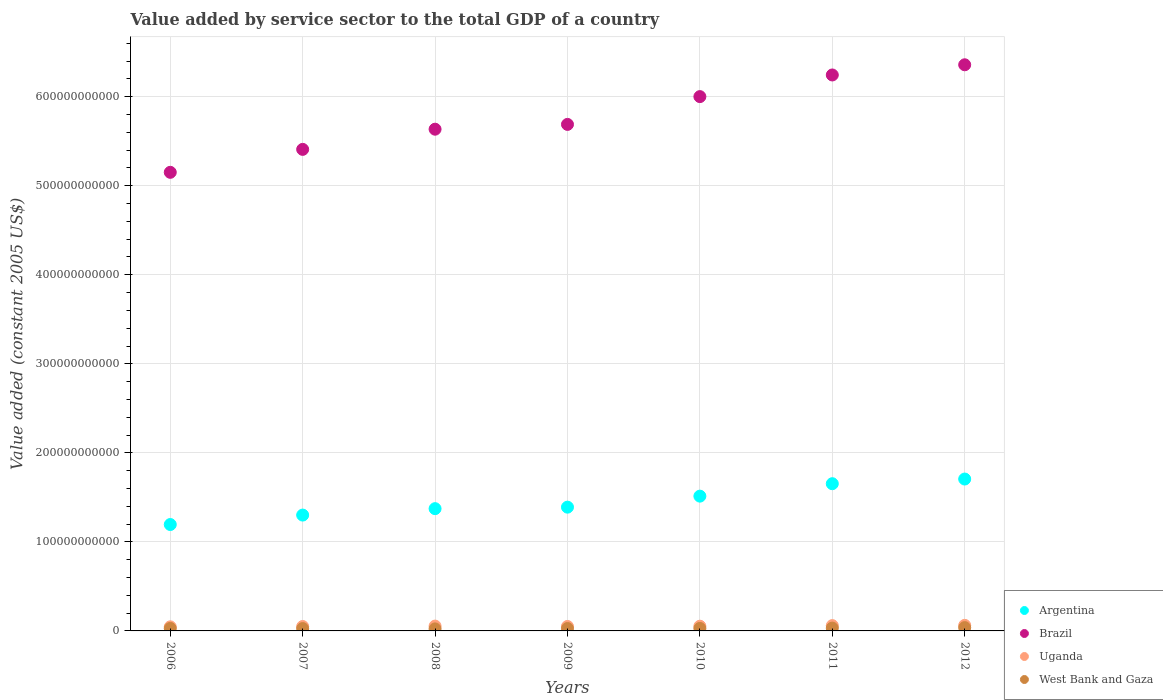What is the value added by service sector in Uganda in 2010?
Your answer should be compact. 5.30e+09. Across all years, what is the maximum value added by service sector in Uganda?
Provide a short and direct response. 6.25e+09. Across all years, what is the minimum value added by service sector in West Bank and Gaza?
Make the answer very short. 2.28e+09. In which year was the value added by service sector in Argentina minimum?
Your answer should be compact. 2006. What is the total value added by service sector in Uganda in the graph?
Keep it short and to the point. 3.75e+1. What is the difference between the value added by service sector in Brazil in 2008 and that in 2010?
Your answer should be very brief. -3.66e+1. What is the difference between the value added by service sector in Argentina in 2006 and the value added by service sector in West Bank and Gaza in 2010?
Keep it short and to the point. 1.17e+11. What is the average value added by service sector in Brazil per year?
Keep it short and to the point. 5.78e+11. In the year 2007, what is the difference between the value added by service sector in Brazil and value added by service sector in West Bank and Gaza?
Your answer should be compact. 5.38e+11. In how many years, is the value added by service sector in Argentina greater than 640000000000 US$?
Your answer should be very brief. 0. What is the ratio of the value added by service sector in Brazil in 2010 to that in 2012?
Your response must be concise. 0.94. Is the value added by service sector in West Bank and Gaza in 2008 less than that in 2012?
Ensure brevity in your answer.  Yes. Is the difference between the value added by service sector in Brazil in 2006 and 2011 greater than the difference between the value added by service sector in West Bank and Gaza in 2006 and 2011?
Ensure brevity in your answer.  No. What is the difference between the highest and the second highest value added by service sector in Argentina?
Your response must be concise. 5.24e+09. What is the difference between the highest and the lowest value added by service sector in Uganda?
Provide a short and direct response. 1.67e+09. In how many years, is the value added by service sector in Brazil greater than the average value added by service sector in Brazil taken over all years?
Your answer should be very brief. 3. Is the sum of the value added by service sector in West Bank and Gaza in 2006 and 2012 greater than the maximum value added by service sector in Uganda across all years?
Your response must be concise. Yes. Is it the case that in every year, the sum of the value added by service sector in Brazil and value added by service sector in Argentina  is greater than the value added by service sector in West Bank and Gaza?
Provide a succinct answer. Yes. Does the value added by service sector in West Bank and Gaza monotonically increase over the years?
Your answer should be compact. No. Is the value added by service sector in West Bank and Gaza strictly greater than the value added by service sector in Brazil over the years?
Offer a terse response. No. How many dotlines are there?
Provide a short and direct response. 4. How many years are there in the graph?
Keep it short and to the point. 7. What is the difference between two consecutive major ticks on the Y-axis?
Your answer should be very brief. 1.00e+11. Does the graph contain any zero values?
Your response must be concise. No. Does the graph contain grids?
Offer a very short reply. Yes. Where does the legend appear in the graph?
Offer a very short reply. Bottom right. How many legend labels are there?
Keep it short and to the point. 4. What is the title of the graph?
Provide a succinct answer. Value added by service sector to the total GDP of a country. Does "Estonia" appear as one of the legend labels in the graph?
Your answer should be very brief. No. What is the label or title of the Y-axis?
Provide a succinct answer. Value added (constant 2005 US$). What is the Value added (constant 2005 US$) in Argentina in 2006?
Offer a terse response. 1.19e+11. What is the Value added (constant 2005 US$) in Brazil in 2006?
Ensure brevity in your answer.  5.15e+11. What is the Value added (constant 2005 US$) of Uganda in 2006?
Give a very brief answer. 4.58e+09. What is the Value added (constant 2005 US$) in West Bank and Gaza in 2006?
Offer a very short reply. 2.79e+09. What is the Value added (constant 2005 US$) of Argentina in 2007?
Provide a succinct answer. 1.30e+11. What is the Value added (constant 2005 US$) of Brazil in 2007?
Ensure brevity in your answer.  5.41e+11. What is the Value added (constant 2005 US$) in Uganda in 2007?
Your answer should be very brief. 4.95e+09. What is the Value added (constant 2005 US$) of West Bank and Gaza in 2007?
Provide a succinct answer. 2.63e+09. What is the Value added (constant 2005 US$) in Argentina in 2008?
Make the answer very short. 1.37e+11. What is the Value added (constant 2005 US$) in Brazil in 2008?
Provide a succinct answer. 5.64e+11. What is the Value added (constant 2005 US$) in Uganda in 2008?
Give a very brief answer. 5.43e+09. What is the Value added (constant 2005 US$) of West Bank and Gaza in 2008?
Give a very brief answer. 2.28e+09. What is the Value added (constant 2005 US$) of Argentina in 2009?
Offer a terse response. 1.39e+11. What is the Value added (constant 2005 US$) of Brazil in 2009?
Offer a terse response. 5.69e+11. What is the Value added (constant 2005 US$) of Uganda in 2009?
Your answer should be very brief. 5.00e+09. What is the Value added (constant 2005 US$) in West Bank and Gaza in 2009?
Offer a very short reply. 2.69e+09. What is the Value added (constant 2005 US$) of Argentina in 2010?
Give a very brief answer. 1.51e+11. What is the Value added (constant 2005 US$) in Brazil in 2010?
Provide a succinct answer. 6.00e+11. What is the Value added (constant 2005 US$) in Uganda in 2010?
Give a very brief answer. 5.30e+09. What is the Value added (constant 2005 US$) in West Bank and Gaza in 2010?
Your answer should be compact. 2.80e+09. What is the Value added (constant 2005 US$) of Argentina in 2011?
Your answer should be compact. 1.65e+11. What is the Value added (constant 2005 US$) of Brazil in 2011?
Offer a very short reply. 6.24e+11. What is the Value added (constant 2005 US$) in Uganda in 2011?
Provide a succinct answer. 5.96e+09. What is the Value added (constant 2005 US$) of West Bank and Gaza in 2011?
Keep it short and to the point. 3.15e+09. What is the Value added (constant 2005 US$) in Argentina in 2012?
Your answer should be compact. 1.71e+11. What is the Value added (constant 2005 US$) in Brazil in 2012?
Offer a very short reply. 6.36e+11. What is the Value added (constant 2005 US$) in Uganda in 2012?
Provide a succinct answer. 6.25e+09. What is the Value added (constant 2005 US$) of West Bank and Gaza in 2012?
Your answer should be very brief. 3.69e+09. Across all years, what is the maximum Value added (constant 2005 US$) in Argentina?
Make the answer very short. 1.71e+11. Across all years, what is the maximum Value added (constant 2005 US$) in Brazil?
Your answer should be very brief. 6.36e+11. Across all years, what is the maximum Value added (constant 2005 US$) in Uganda?
Give a very brief answer. 6.25e+09. Across all years, what is the maximum Value added (constant 2005 US$) in West Bank and Gaza?
Provide a short and direct response. 3.69e+09. Across all years, what is the minimum Value added (constant 2005 US$) in Argentina?
Keep it short and to the point. 1.19e+11. Across all years, what is the minimum Value added (constant 2005 US$) of Brazil?
Provide a succinct answer. 5.15e+11. Across all years, what is the minimum Value added (constant 2005 US$) of Uganda?
Provide a succinct answer. 4.58e+09. Across all years, what is the minimum Value added (constant 2005 US$) of West Bank and Gaza?
Your answer should be compact. 2.28e+09. What is the total Value added (constant 2005 US$) in Argentina in the graph?
Provide a succinct answer. 1.01e+12. What is the total Value added (constant 2005 US$) of Brazil in the graph?
Offer a very short reply. 4.05e+12. What is the total Value added (constant 2005 US$) of Uganda in the graph?
Your answer should be compact. 3.75e+1. What is the total Value added (constant 2005 US$) of West Bank and Gaza in the graph?
Keep it short and to the point. 2.00e+1. What is the difference between the Value added (constant 2005 US$) of Argentina in 2006 and that in 2007?
Provide a succinct answer. -1.06e+1. What is the difference between the Value added (constant 2005 US$) in Brazil in 2006 and that in 2007?
Offer a terse response. -2.58e+1. What is the difference between the Value added (constant 2005 US$) of Uganda in 2006 and that in 2007?
Your answer should be very brief. -3.69e+08. What is the difference between the Value added (constant 2005 US$) of West Bank and Gaza in 2006 and that in 2007?
Provide a short and direct response. 1.53e+08. What is the difference between the Value added (constant 2005 US$) of Argentina in 2006 and that in 2008?
Keep it short and to the point. -1.78e+1. What is the difference between the Value added (constant 2005 US$) in Brazil in 2006 and that in 2008?
Make the answer very short. -4.84e+1. What is the difference between the Value added (constant 2005 US$) in Uganda in 2006 and that in 2008?
Make the answer very short. -8.47e+08. What is the difference between the Value added (constant 2005 US$) in West Bank and Gaza in 2006 and that in 2008?
Offer a terse response. 5.07e+08. What is the difference between the Value added (constant 2005 US$) in Argentina in 2006 and that in 2009?
Keep it short and to the point. -1.95e+1. What is the difference between the Value added (constant 2005 US$) of Brazil in 2006 and that in 2009?
Give a very brief answer. -5.38e+1. What is the difference between the Value added (constant 2005 US$) of Uganda in 2006 and that in 2009?
Make the answer very short. -4.21e+08. What is the difference between the Value added (constant 2005 US$) of West Bank and Gaza in 2006 and that in 2009?
Offer a very short reply. 9.29e+07. What is the difference between the Value added (constant 2005 US$) in Argentina in 2006 and that in 2010?
Make the answer very short. -3.19e+1. What is the difference between the Value added (constant 2005 US$) in Brazil in 2006 and that in 2010?
Your response must be concise. -8.50e+1. What is the difference between the Value added (constant 2005 US$) in Uganda in 2006 and that in 2010?
Provide a short and direct response. -7.18e+08. What is the difference between the Value added (constant 2005 US$) of West Bank and Gaza in 2006 and that in 2010?
Your answer should be compact. -1.87e+07. What is the difference between the Value added (constant 2005 US$) of Argentina in 2006 and that in 2011?
Your answer should be very brief. -4.58e+1. What is the difference between the Value added (constant 2005 US$) of Brazil in 2006 and that in 2011?
Your answer should be compact. -1.09e+11. What is the difference between the Value added (constant 2005 US$) of Uganda in 2006 and that in 2011?
Keep it short and to the point. -1.37e+09. What is the difference between the Value added (constant 2005 US$) of West Bank and Gaza in 2006 and that in 2011?
Your answer should be very brief. -3.64e+08. What is the difference between the Value added (constant 2005 US$) of Argentina in 2006 and that in 2012?
Keep it short and to the point. -5.11e+1. What is the difference between the Value added (constant 2005 US$) in Brazil in 2006 and that in 2012?
Provide a short and direct response. -1.21e+11. What is the difference between the Value added (constant 2005 US$) of Uganda in 2006 and that in 2012?
Provide a short and direct response. -1.67e+09. What is the difference between the Value added (constant 2005 US$) of West Bank and Gaza in 2006 and that in 2012?
Provide a succinct answer. -9.06e+08. What is the difference between the Value added (constant 2005 US$) in Argentina in 2007 and that in 2008?
Offer a very short reply. -7.21e+09. What is the difference between the Value added (constant 2005 US$) of Brazil in 2007 and that in 2008?
Provide a short and direct response. -2.27e+1. What is the difference between the Value added (constant 2005 US$) in Uganda in 2007 and that in 2008?
Your answer should be compact. -4.78e+08. What is the difference between the Value added (constant 2005 US$) in West Bank and Gaza in 2007 and that in 2008?
Ensure brevity in your answer.  3.54e+08. What is the difference between the Value added (constant 2005 US$) in Argentina in 2007 and that in 2009?
Your response must be concise. -8.89e+09. What is the difference between the Value added (constant 2005 US$) in Brazil in 2007 and that in 2009?
Provide a short and direct response. -2.81e+1. What is the difference between the Value added (constant 2005 US$) of Uganda in 2007 and that in 2009?
Provide a short and direct response. -5.24e+07. What is the difference between the Value added (constant 2005 US$) in West Bank and Gaza in 2007 and that in 2009?
Your answer should be compact. -5.98e+07. What is the difference between the Value added (constant 2005 US$) of Argentina in 2007 and that in 2010?
Your answer should be compact. -2.13e+1. What is the difference between the Value added (constant 2005 US$) in Brazil in 2007 and that in 2010?
Provide a short and direct response. -5.93e+1. What is the difference between the Value added (constant 2005 US$) in Uganda in 2007 and that in 2010?
Keep it short and to the point. -3.49e+08. What is the difference between the Value added (constant 2005 US$) of West Bank and Gaza in 2007 and that in 2010?
Provide a short and direct response. -1.71e+08. What is the difference between the Value added (constant 2005 US$) in Argentina in 2007 and that in 2011?
Ensure brevity in your answer.  -3.52e+1. What is the difference between the Value added (constant 2005 US$) of Brazil in 2007 and that in 2011?
Your answer should be compact. -8.36e+1. What is the difference between the Value added (constant 2005 US$) of Uganda in 2007 and that in 2011?
Offer a terse response. -1.00e+09. What is the difference between the Value added (constant 2005 US$) of West Bank and Gaza in 2007 and that in 2011?
Make the answer very short. -5.17e+08. What is the difference between the Value added (constant 2005 US$) of Argentina in 2007 and that in 2012?
Provide a succinct answer. -4.05e+1. What is the difference between the Value added (constant 2005 US$) in Brazil in 2007 and that in 2012?
Give a very brief answer. -9.50e+1. What is the difference between the Value added (constant 2005 US$) of Uganda in 2007 and that in 2012?
Provide a short and direct response. -1.30e+09. What is the difference between the Value added (constant 2005 US$) of West Bank and Gaza in 2007 and that in 2012?
Offer a terse response. -1.06e+09. What is the difference between the Value added (constant 2005 US$) in Argentina in 2008 and that in 2009?
Offer a very short reply. -1.68e+09. What is the difference between the Value added (constant 2005 US$) of Brazil in 2008 and that in 2009?
Make the answer very short. -5.39e+09. What is the difference between the Value added (constant 2005 US$) in Uganda in 2008 and that in 2009?
Offer a terse response. 4.26e+08. What is the difference between the Value added (constant 2005 US$) in West Bank and Gaza in 2008 and that in 2009?
Ensure brevity in your answer.  -4.14e+08. What is the difference between the Value added (constant 2005 US$) of Argentina in 2008 and that in 2010?
Offer a terse response. -1.41e+1. What is the difference between the Value added (constant 2005 US$) in Brazil in 2008 and that in 2010?
Keep it short and to the point. -3.66e+1. What is the difference between the Value added (constant 2005 US$) of Uganda in 2008 and that in 2010?
Offer a very short reply. 1.29e+08. What is the difference between the Value added (constant 2005 US$) in West Bank and Gaza in 2008 and that in 2010?
Give a very brief answer. -5.26e+08. What is the difference between the Value added (constant 2005 US$) in Argentina in 2008 and that in 2011?
Your answer should be compact. -2.80e+1. What is the difference between the Value added (constant 2005 US$) in Brazil in 2008 and that in 2011?
Offer a terse response. -6.09e+1. What is the difference between the Value added (constant 2005 US$) in Uganda in 2008 and that in 2011?
Your answer should be very brief. -5.27e+08. What is the difference between the Value added (constant 2005 US$) in West Bank and Gaza in 2008 and that in 2011?
Give a very brief answer. -8.71e+08. What is the difference between the Value added (constant 2005 US$) of Argentina in 2008 and that in 2012?
Make the answer very short. -3.33e+1. What is the difference between the Value added (constant 2005 US$) of Brazil in 2008 and that in 2012?
Offer a terse response. -7.24e+1. What is the difference between the Value added (constant 2005 US$) of Uganda in 2008 and that in 2012?
Your answer should be very brief. -8.21e+08. What is the difference between the Value added (constant 2005 US$) in West Bank and Gaza in 2008 and that in 2012?
Keep it short and to the point. -1.41e+09. What is the difference between the Value added (constant 2005 US$) of Argentina in 2009 and that in 2010?
Your answer should be compact. -1.24e+1. What is the difference between the Value added (constant 2005 US$) in Brazil in 2009 and that in 2010?
Offer a terse response. -3.12e+1. What is the difference between the Value added (constant 2005 US$) of Uganda in 2009 and that in 2010?
Keep it short and to the point. -2.97e+08. What is the difference between the Value added (constant 2005 US$) in West Bank and Gaza in 2009 and that in 2010?
Your answer should be compact. -1.12e+08. What is the difference between the Value added (constant 2005 US$) in Argentina in 2009 and that in 2011?
Your response must be concise. -2.63e+1. What is the difference between the Value added (constant 2005 US$) of Brazil in 2009 and that in 2011?
Offer a very short reply. -5.55e+1. What is the difference between the Value added (constant 2005 US$) of Uganda in 2009 and that in 2011?
Give a very brief answer. -9.52e+08. What is the difference between the Value added (constant 2005 US$) of West Bank and Gaza in 2009 and that in 2011?
Your answer should be very brief. -4.57e+08. What is the difference between the Value added (constant 2005 US$) of Argentina in 2009 and that in 2012?
Ensure brevity in your answer.  -3.16e+1. What is the difference between the Value added (constant 2005 US$) in Brazil in 2009 and that in 2012?
Provide a short and direct response. -6.70e+1. What is the difference between the Value added (constant 2005 US$) in Uganda in 2009 and that in 2012?
Your response must be concise. -1.25e+09. What is the difference between the Value added (constant 2005 US$) of West Bank and Gaza in 2009 and that in 2012?
Keep it short and to the point. -9.99e+08. What is the difference between the Value added (constant 2005 US$) of Argentina in 2010 and that in 2011?
Provide a short and direct response. -1.40e+1. What is the difference between the Value added (constant 2005 US$) of Brazil in 2010 and that in 2011?
Your answer should be compact. -2.43e+1. What is the difference between the Value added (constant 2005 US$) in Uganda in 2010 and that in 2011?
Offer a terse response. -6.55e+08. What is the difference between the Value added (constant 2005 US$) in West Bank and Gaza in 2010 and that in 2011?
Give a very brief answer. -3.45e+08. What is the difference between the Value added (constant 2005 US$) of Argentina in 2010 and that in 2012?
Your answer should be very brief. -1.92e+1. What is the difference between the Value added (constant 2005 US$) of Brazil in 2010 and that in 2012?
Your answer should be very brief. -3.57e+1. What is the difference between the Value added (constant 2005 US$) of Uganda in 2010 and that in 2012?
Provide a succinct answer. -9.49e+08. What is the difference between the Value added (constant 2005 US$) in West Bank and Gaza in 2010 and that in 2012?
Ensure brevity in your answer.  -8.88e+08. What is the difference between the Value added (constant 2005 US$) in Argentina in 2011 and that in 2012?
Keep it short and to the point. -5.24e+09. What is the difference between the Value added (constant 2005 US$) of Brazil in 2011 and that in 2012?
Your answer should be very brief. -1.14e+1. What is the difference between the Value added (constant 2005 US$) in Uganda in 2011 and that in 2012?
Make the answer very short. -2.94e+08. What is the difference between the Value added (constant 2005 US$) in West Bank and Gaza in 2011 and that in 2012?
Offer a very short reply. -5.42e+08. What is the difference between the Value added (constant 2005 US$) in Argentina in 2006 and the Value added (constant 2005 US$) in Brazil in 2007?
Your response must be concise. -4.21e+11. What is the difference between the Value added (constant 2005 US$) of Argentina in 2006 and the Value added (constant 2005 US$) of Uganda in 2007?
Your answer should be compact. 1.15e+11. What is the difference between the Value added (constant 2005 US$) in Argentina in 2006 and the Value added (constant 2005 US$) in West Bank and Gaza in 2007?
Your answer should be very brief. 1.17e+11. What is the difference between the Value added (constant 2005 US$) of Brazil in 2006 and the Value added (constant 2005 US$) of Uganda in 2007?
Your answer should be compact. 5.10e+11. What is the difference between the Value added (constant 2005 US$) of Brazil in 2006 and the Value added (constant 2005 US$) of West Bank and Gaza in 2007?
Offer a terse response. 5.12e+11. What is the difference between the Value added (constant 2005 US$) of Uganda in 2006 and the Value added (constant 2005 US$) of West Bank and Gaza in 2007?
Make the answer very short. 1.95e+09. What is the difference between the Value added (constant 2005 US$) in Argentina in 2006 and the Value added (constant 2005 US$) in Brazil in 2008?
Give a very brief answer. -4.44e+11. What is the difference between the Value added (constant 2005 US$) of Argentina in 2006 and the Value added (constant 2005 US$) of Uganda in 2008?
Your response must be concise. 1.14e+11. What is the difference between the Value added (constant 2005 US$) in Argentina in 2006 and the Value added (constant 2005 US$) in West Bank and Gaza in 2008?
Your answer should be compact. 1.17e+11. What is the difference between the Value added (constant 2005 US$) in Brazil in 2006 and the Value added (constant 2005 US$) in Uganda in 2008?
Your answer should be compact. 5.10e+11. What is the difference between the Value added (constant 2005 US$) of Brazil in 2006 and the Value added (constant 2005 US$) of West Bank and Gaza in 2008?
Offer a very short reply. 5.13e+11. What is the difference between the Value added (constant 2005 US$) in Uganda in 2006 and the Value added (constant 2005 US$) in West Bank and Gaza in 2008?
Offer a very short reply. 2.30e+09. What is the difference between the Value added (constant 2005 US$) of Argentina in 2006 and the Value added (constant 2005 US$) of Brazil in 2009?
Provide a succinct answer. -4.49e+11. What is the difference between the Value added (constant 2005 US$) of Argentina in 2006 and the Value added (constant 2005 US$) of Uganda in 2009?
Ensure brevity in your answer.  1.14e+11. What is the difference between the Value added (constant 2005 US$) of Argentina in 2006 and the Value added (constant 2005 US$) of West Bank and Gaza in 2009?
Ensure brevity in your answer.  1.17e+11. What is the difference between the Value added (constant 2005 US$) of Brazil in 2006 and the Value added (constant 2005 US$) of Uganda in 2009?
Provide a short and direct response. 5.10e+11. What is the difference between the Value added (constant 2005 US$) of Brazil in 2006 and the Value added (constant 2005 US$) of West Bank and Gaza in 2009?
Offer a very short reply. 5.12e+11. What is the difference between the Value added (constant 2005 US$) of Uganda in 2006 and the Value added (constant 2005 US$) of West Bank and Gaza in 2009?
Your answer should be very brief. 1.89e+09. What is the difference between the Value added (constant 2005 US$) of Argentina in 2006 and the Value added (constant 2005 US$) of Brazil in 2010?
Your response must be concise. -4.81e+11. What is the difference between the Value added (constant 2005 US$) of Argentina in 2006 and the Value added (constant 2005 US$) of Uganda in 2010?
Your answer should be very brief. 1.14e+11. What is the difference between the Value added (constant 2005 US$) of Argentina in 2006 and the Value added (constant 2005 US$) of West Bank and Gaza in 2010?
Give a very brief answer. 1.17e+11. What is the difference between the Value added (constant 2005 US$) in Brazil in 2006 and the Value added (constant 2005 US$) in Uganda in 2010?
Give a very brief answer. 5.10e+11. What is the difference between the Value added (constant 2005 US$) of Brazil in 2006 and the Value added (constant 2005 US$) of West Bank and Gaza in 2010?
Your response must be concise. 5.12e+11. What is the difference between the Value added (constant 2005 US$) in Uganda in 2006 and the Value added (constant 2005 US$) in West Bank and Gaza in 2010?
Provide a short and direct response. 1.78e+09. What is the difference between the Value added (constant 2005 US$) in Argentina in 2006 and the Value added (constant 2005 US$) in Brazil in 2011?
Your answer should be compact. -5.05e+11. What is the difference between the Value added (constant 2005 US$) in Argentina in 2006 and the Value added (constant 2005 US$) in Uganda in 2011?
Your answer should be compact. 1.14e+11. What is the difference between the Value added (constant 2005 US$) of Argentina in 2006 and the Value added (constant 2005 US$) of West Bank and Gaza in 2011?
Keep it short and to the point. 1.16e+11. What is the difference between the Value added (constant 2005 US$) in Brazil in 2006 and the Value added (constant 2005 US$) in Uganda in 2011?
Offer a very short reply. 5.09e+11. What is the difference between the Value added (constant 2005 US$) in Brazil in 2006 and the Value added (constant 2005 US$) in West Bank and Gaza in 2011?
Make the answer very short. 5.12e+11. What is the difference between the Value added (constant 2005 US$) in Uganda in 2006 and the Value added (constant 2005 US$) in West Bank and Gaza in 2011?
Your answer should be very brief. 1.43e+09. What is the difference between the Value added (constant 2005 US$) in Argentina in 2006 and the Value added (constant 2005 US$) in Brazil in 2012?
Provide a short and direct response. -5.16e+11. What is the difference between the Value added (constant 2005 US$) of Argentina in 2006 and the Value added (constant 2005 US$) of Uganda in 2012?
Ensure brevity in your answer.  1.13e+11. What is the difference between the Value added (constant 2005 US$) in Argentina in 2006 and the Value added (constant 2005 US$) in West Bank and Gaza in 2012?
Provide a short and direct response. 1.16e+11. What is the difference between the Value added (constant 2005 US$) in Brazil in 2006 and the Value added (constant 2005 US$) in Uganda in 2012?
Offer a very short reply. 5.09e+11. What is the difference between the Value added (constant 2005 US$) of Brazil in 2006 and the Value added (constant 2005 US$) of West Bank and Gaza in 2012?
Make the answer very short. 5.11e+11. What is the difference between the Value added (constant 2005 US$) in Uganda in 2006 and the Value added (constant 2005 US$) in West Bank and Gaza in 2012?
Offer a very short reply. 8.89e+08. What is the difference between the Value added (constant 2005 US$) of Argentina in 2007 and the Value added (constant 2005 US$) of Brazil in 2008?
Provide a short and direct response. -4.33e+11. What is the difference between the Value added (constant 2005 US$) of Argentina in 2007 and the Value added (constant 2005 US$) of Uganda in 2008?
Your answer should be compact. 1.25e+11. What is the difference between the Value added (constant 2005 US$) of Argentina in 2007 and the Value added (constant 2005 US$) of West Bank and Gaza in 2008?
Ensure brevity in your answer.  1.28e+11. What is the difference between the Value added (constant 2005 US$) of Brazil in 2007 and the Value added (constant 2005 US$) of Uganda in 2008?
Provide a succinct answer. 5.35e+11. What is the difference between the Value added (constant 2005 US$) in Brazil in 2007 and the Value added (constant 2005 US$) in West Bank and Gaza in 2008?
Provide a short and direct response. 5.39e+11. What is the difference between the Value added (constant 2005 US$) of Uganda in 2007 and the Value added (constant 2005 US$) of West Bank and Gaza in 2008?
Your answer should be compact. 2.67e+09. What is the difference between the Value added (constant 2005 US$) of Argentina in 2007 and the Value added (constant 2005 US$) of Brazil in 2009?
Give a very brief answer. -4.39e+11. What is the difference between the Value added (constant 2005 US$) in Argentina in 2007 and the Value added (constant 2005 US$) in Uganda in 2009?
Your answer should be very brief. 1.25e+11. What is the difference between the Value added (constant 2005 US$) in Argentina in 2007 and the Value added (constant 2005 US$) in West Bank and Gaza in 2009?
Your answer should be very brief. 1.27e+11. What is the difference between the Value added (constant 2005 US$) in Brazil in 2007 and the Value added (constant 2005 US$) in Uganda in 2009?
Make the answer very short. 5.36e+11. What is the difference between the Value added (constant 2005 US$) of Brazil in 2007 and the Value added (constant 2005 US$) of West Bank and Gaza in 2009?
Make the answer very short. 5.38e+11. What is the difference between the Value added (constant 2005 US$) of Uganda in 2007 and the Value added (constant 2005 US$) of West Bank and Gaza in 2009?
Ensure brevity in your answer.  2.26e+09. What is the difference between the Value added (constant 2005 US$) in Argentina in 2007 and the Value added (constant 2005 US$) in Brazil in 2010?
Give a very brief answer. -4.70e+11. What is the difference between the Value added (constant 2005 US$) of Argentina in 2007 and the Value added (constant 2005 US$) of Uganda in 2010?
Offer a terse response. 1.25e+11. What is the difference between the Value added (constant 2005 US$) of Argentina in 2007 and the Value added (constant 2005 US$) of West Bank and Gaza in 2010?
Keep it short and to the point. 1.27e+11. What is the difference between the Value added (constant 2005 US$) of Brazil in 2007 and the Value added (constant 2005 US$) of Uganda in 2010?
Your answer should be very brief. 5.36e+11. What is the difference between the Value added (constant 2005 US$) of Brazil in 2007 and the Value added (constant 2005 US$) of West Bank and Gaza in 2010?
Offer a very short reply. 5.38e+11. What is the difference between the Value added (constant 2005 US$) of Uganda in 2007 and the Value added (constant 2005 US$) of West Bank and Gaza in 2010?
Your answer should be very brief. 2.15e+09. What is the difference between the Value added (constant 2005 US$) in Argentina in 2007 and the Value added (constant 2005 US$) in Brazil in 2011?
Give a very brief answer. -4.94e+11. What is the difference between the Value added (constant 2005 US$) in Argentina in 2007 and the Value added (constant 2005 US$) in Uganda in 2011?
Make the answer very short. 1.24e+11. What is the difference between the Value added (constant 2005 US$) of Argentina in 2007 and the Value added (constant 2005 US$) of West Bank and Gaza in 2011?
Offer a terse response. 1.27e+11. What is the difference between the Value added (constant 2005 US$) in Brazil in 2007 and the Value added (constant 2005 US$) in Uganda in 2011?
Give a very brief answer. 5.35e+11. What is the difference between the Value added (constant 2005 US$) in Brazil in 2007 and the Value added (constant 2005 US$) in West Bank and Gaza in 2011?
Provide a short and direct response. 5.38e+11. What is the difference between the Value added (constant 2005 US$) in Uganda in 2007 and the Value added (constant 2005 US$) in West Bank and Gaza in 2011?
Provide a succinct answer. 1.80e+09. What is the difference between the Value added (constant 2005 US$) of Argentina in 2007 and the Value added (constant 2005 US$) of Brazil in 2012?
Make the answer very short. -5.06e+11. What is the difference between the Value added (constant 2005 US$) in Argentina in 2007 and the Value added (constant 2005 US$) in Uganda in 2012?
Offer a terse response. 1.24e+11. What is the difference between the Value added (constant 2005 US$) in Argentina in 2007 and the Value added (constant 2005 US$) in West Bank and Gaza in 2012?
Ensure brevity in your answer.  1.26e+11. What is the difference between the Value added (constant 2005 US$) of Brazil in 2007 and the Value added (constant 2005 US$) of Uganda in 2012?
Offer a terse response. 5.35e+11. What is the difference between the Value added (constant 2005 US$) of Brazil in 2007 and the Value added (constant 2005 US$) of West Bank and Gaza in 2012?
Your answer should be compact. 5.37e+11. What is the difference between the Value added (constant 2005 US$) in Uganda in 2007 and the Value added (constant 2005 US$) in West Bank and Gaza in 2012?
Your answer should be very brief. 1.26e+09. What is the difference between the Value added (constant 2005 US$) in Argentina in 2008 and the Value added (constant 2005 US$) in Brazil in 2009?
Give a very brief answer. -4.32e+11. What is the difference between the Value added (constant 2005 US$) of Argentina in 2008 and the Value added (constant 2005 US$) of Uganda in 2009?
Ensure brevity in your answer.  1.32e+11. What is the difference between the Value added (constant 2005 US$) in Argentina in 2008 and the Value added (constant 2005 US$) in West Bank and Gaza in 2009?
Your response must be concise. 1.35e+11. What is the difference between the Value added (constant 2005 US$) of Brazil in 2008 and the Value added (constant 2005 US$) of Uganda in 2009?
Provide a succinct answer. 5.59e+11. What is the difference between the Value added (constant 2005 US$) of Brazil in 2008 and the Value added (constant 2005 US$) of West Bank and Gaza in 2009?
Provide a succinct answer. 5.61e+11. What is the difference between the Value added (constant 2005 US$) of Uganda in 2008 and the Value added (constant 2005 US$) of West Bank and Gaza in 2009?
Give a very brief answer. 2.74e+09. What is the difference between the Value added (constant 2005 US$) of Argentina in 2008 and the Value added (constant 2005 US$) of Brazil in 2010?
Provide a succinct answer. -4.63e+11. What is the difference between the Value added (constant 2005 US$) of Argentina in 2008 and the Value added (constant 2005 US$) of Uganda in 2010?
Make the answer very short. 1.32e+11. What is the difference between the Value added (constant 2005 US$) in Argentina in 2008 and the Value added (constant 2005 US$) in West Bank and Gaza in 2010?
Ensure brevity in your answer.  1.35e+11. What is the difference between the Value added (constant 2005 US$) in Brazil in 2008 and the Value added (constant 2005 US$) in Uganda in 2010?
Make the answer very short. 5.58e+11. What is the difference between the Value added (constant 2005 US$) of Brazil in 2008 and the Value added (constant 2005 US$) of West Bank and Gaza in 2010?
Keep it short and to the point. 5.61e+11. What is the difference between the Value added (constant 2005 US$) in Uganda in 2008 and the Value added (constant 2005 US$) in West Bank and Gaza in 2010?
Offer a very short reply. 2.62e+09. What is the difference between the Value added (constant 2005 US$) in Argentina in 2008 and the Value added (constant 2005 US$) in Brazil in 2011?
Ensure brevity in your answer.  -4.87e+11. What is the difference between the Value added (constant 2005 US$) in Argentina in 2008 and the Value added (constant 2005 US$) in Uganda in 2011?
Offer a terse response. 1.31e+11. What is the difference between the Value added (constant 2005 US$) in Argentina in 2008 and the Value added (constant 2005 US$) in West Bank and Gaza in 2011?
Your answer should be compact. 1.34e+11. What is the difference between the Value added (constant 2005 US$) of Brazil in 2008 and the Value added (constant 2005 US$) of Uganda in 2011?
Give a very brief answer. 5.58e+11. What is the difference between the Value added (constant 2005 US$) of Brazil in 2008 and the Value added (constant 2005 US$) of West Bank and Gaza in 2011?
Keep it short and to the point. 5.60e+11. What is the difference between the Value added (constant 2005 US$) of Uganda in 2008 and the Value added (constant 2005 US$) of West Bank and Gaza in 2011?
Keep it short and to the point. 2.28e+09. What is the difference between the Value added (constant 2005 US$) in Argentina in 2008 and the Value added (constant 2005 US$) in Brazil in 2012?
Offer a terse response. -4.99e+11. What is the difference between the Value added (constant 2005 US$) in Argentina in 2008 and the Value added (constant 2005 US$) in Uganda in 2012?
Give a very brief answer. 1.31e+11. What is the difference between the Value added (constant 2005 US$) in Argentina in 2008 and the Value added (constant 2005 US$) in West Bank and Gaza in 2012?
Your answer should be very brief. 1.34e+11. What is the difference between the Value added (constant 2005 US$) in Brazil in 2008 and the Value added (constant 2005 US$) in Uganda in 2012?
Your response must be concise. 5.57e+11. What is the difference between the Value added (constant 2005 US$) in Brazil in 2008 and the Value added (constant 2005 US$) in West Bank and Gaza in 2012?
Offer a terse response. 5.60e+11. What is the difference between the Value added (constant 2005 US$) of Uganda in 2008 and the Value added (constant 2005 US$) of West Bank and Gaza in 2012?
Keep it short and to the point. 1.74e+09. What is the difference between the Value added (constant 2005 US$) in Argentina in 2009 and the Value added (constant 2005 US$) in Brazil in 2010?
Your response must be concise. -4.61e+11. What is the difference between the Value added (constant 2005 US$) of Argentina in 2009 and the Value added (constant 2005 US$) of Uganda in 2010?
Your answer should be very brief. 1.34e+11. What is the difference between the Value added (constant 2005 US$) in Argentina in 2009 and the Value added (constant 2005 US$) in West Bank and Gaza in 2010?
Provide a short and direct response. 1.36e+11. What is the difference between the Value added (constant 2005 US$) of Brazil in 2009 and the Value added (constant 2005 US$) of Uganda in 2010?
Offer a very short reply. 5.64e+11. What is the difference between the Value added (constant 2005 US$) in Brazil in 2009 and the Value added (constant 2005 US$) in West Bank and Gaza in 2010?
Offer a very short reply. 5.66e+11. What is the difference between the Value added (constant 2005 US$) in Uganda in 2009 and the Value added (constant 2005 US$) in West Bank and Gaza in 2010?
Your answer should be compact. 2.20e+09. What is the difference between the Value added (constant 2005 US$) in Argentina in 2009 and the Value added (constant 2005 US$) in Brazil in 2011?
Offer a terse response. -4.85e+11. What is the difference between the Value added (constant 2005 US$) in Argentina in 2009 and the Value added (constant 2005 US$) in Uganda in 2011?
Ensure brevity in your answer.  1.33e+11. What is the difference between the Value added (constant 2005 US$) in Argentina in 2009 and the Value added (constant 2005 US$) in West Bank and Gaza in 2011?
Provide a short and direct response. 1.36e+11. What is the difference between the Value added (constant 2005 US$) of Brazil in 2009 and the Value added (constant 2005 US$) of Uganda in 2011?
Keep it short and to the point. 5.63e+11. What is the difference between the Value added (constant 2005 US$) of Brazil in 2009 and the Value added (constant 2005 US$) of West Bank and Gaza in 2011?
Offer a very short reply. 5.66e+11. What is the difference between the Value added (constant 2005 US$) in Uganda in 2009 and the Value added (constant 2005 US$) in West Bank and Gaza in 2011?
Your answer should be very brief. 1.85e+09. What is the difference between the Value added (constant 2005 US$) of Argentina in 2009 and the Value added (constant 2005 US$) of Brazil in 2012?
Give a very brief answer. -4.97e+11. What is the difference between the Value added (constant 2005 US$) in Argentina in 2009 and the Value added (constant 2005 US$) in Uganda in 2012?
Your answer should be very brief. 1.33e+11. What is the difference between the Value added (constant 2005 US$) of Argentina in 2009 and the Value added (constant 2005 US$) of West Bank and Gaza in 2012?
Offer a terse response. 1.35e+11. What is the difference between the Value added (constant 2005 US$) of Brazil in 2009 and the Value added (constant 2005 US$) of Uganda in 2012?
Make the answer very short. 5.63e+11. What is the difference between the Value added (constant 2005 US$) of Brazil in 2009 and the Value added (constant 2005 US$) of West Bank and Gaza in 2012?
Keep it short and to the point. 5.65e+11. What is the difference between the Value added (constant 2005 US$) of Uganda in 2009 and the Value added (constant 2005 US$) of West Bank and Gaza in 2012?
Ensure brevity in your answer.  1.31e+09. What is the difference between the Value added (constant 2005 US$) of Argentina in 2010 and the Value added (constant 2005 US$) of Brazil in 2011?
Your response must be concise. -4.73e+11. What is the difference between the Value added (constant 2005 US$) of Argentina in 2010 and the Value added (constant 2005 US$) of Uganda in 2011?
Your answer should be very brief. 1.45e+11. What is the difference between the Value added (constant 2005 US$) of Argentina in 2010 and the Value added (constant 2005 US$) of West Bank and Gaza in 2011?
Your answer should be very brief. 1.48e+11. What is the difference between the Value added (constant 2005 US$) in Brazil in 2010 and the Value added (constant 2005 US$) in Uganda in 2011?
Give a very brief answer. 5.94e+11. What is the difference between the Value added (constant 2005 US$) of Brazil in 2010 and the Value added (constant 2005 US$) of West Bank and Gaza in 2011?
Ensure brevity in your answer.  5.97e+11. What is the difference between the Value added (constant 2005 US$) of Uganda in 2010 and the Value added (constant 2005 US$) of West Bank and Gaza in 2011?
Keep it short and to the point. 2.15e+09. What is the difference between the Value added (constant 2005 US$) in Argentina in 2010 and the Value added (constant 2005 US$) in Brazil in 2012?
Offer a terse response. -4.84e+11. What is the difference between the Value added (constant 2005 US$) in Argentina in 2010 and the Value added (constant 2005 US$) in Uganda in 2012?
Your response must be concise. 1.45e+11. What is the difference between the Value added (constant 2005 US$) of Argentina in 2010 and the Value added (constant 2005 US$) of West Bank and Gaza in 2012?
Provide a short and direct response. 1.48e+11. What is the difference between the Value added (constant 2005 US$) in Brazil in 2010 and the Value added (constant 2005 US$) in Uganda in 2012?
Give a very brief answer. 5.94e+11. What is the difference between the Value added (constant 2005 US$) in Brazil in 2010 and the Value added (constant 2005 US$) in West Bank and Gaza in 2012?
Your answer should be very brief. 5.96e+11. What is the difference between the Value added (constant 2005 US$) in Uganda in 2010 and the Value added (constant 2005 US$) in West Bank and Gaza in 2012?
Offer a terse response. 1.61e+09. What is the difference between the Value added (constant 2005 US$) in Argentina in 2011 and the Value added (constant 2005 US$) in Brazil in 2012?
Offer a terse response. -4.71e+11. What is the difference between the Value added (constant 2005 US$) of Argentina in 2011 and the Value added (constant 2005 US$) of Uganda in 2012?
Make the answer very short. 1.59e+11. What is the difference between the Value added (constant 2005 US$) of Argentina in 2011 and the Value added (constant 2005 US$) of West Bank and Gaza in 2012?
Your answer should be compact. 1.62e+11. What is the difference between the Value added (constant 2005 US$) in Brazil in 2011 and the Value added (constant 2005 US$) in Uganda in 2012?
Offer a terse response. 6.18e+11. What is the difference between the Value added (constant 2005 US$) in Brazil in 2011 and the Value added (constant 2005 US$) in West Bank and Gaza in 2012?
Provide a succinct answer. 6.21e+11. What is the difference between the Value added (constant 2005 US$) in Uganda in 2011 and the Value added (constant 2005 US$) in West Bank and Gaza in 2012?
Make the answer very short. 2.26e+09. What is the average Value added (constant 2005 US$) in Argentina per year?
Your answer should be compact. 1.45e+11. What is the average Value added (constant 2005 US$) in Brazil per year?
Make the answer very short. 5.78e+11. What is the average Value added (constant 2005 US$) in Uganda per year?
Make the answer very short. 5.35e+09. What is the average Value added (constant 2005 US$) of West Bank and Gaza per year?
Make the answer very short. 2.86e+09. In the year 2006, what is the difference between the Value added (constant 2005 US$) in Argentina and Value added (constant 2005 US$) in Brazil?
Offer a terse response. -3.96e+11. In the year 2006, what is the difference between the Value added (constant 2005 US$) in Argentina and Value added (constant 2005 US$) in Uganda?
Give a very brief answer. 1.15e+11. In the year 2006, what is the difference between the Value added (constant 2005 US$) of Argentina and Value added (constant 2005 US$) of West Bank and Gaza?
Provide a succinct answer. 1.17e+11. In the year 2006, what is the difference between the Value added (constant 2005 US$) in Brazil and Value added (constant 2005 US$) in Uganda?
Offer a terse response. 5.10e+11. In the year 2006, what is the difference between the Value added (constant 2005 US$) in Brazil and Value added (constant 2005 US$) in West Bank and Gaza?
Provide a short and direct response. 5.12e+11. In the year 2006, what is the difference between the Value added (constant 2005 US$) of Uganda and Value added (constant 2005 US$) of West Bank and Gaza?
Your response must be concise. 1.80e+09. In the year 2007, what is the difference between the Value added (constant 2005 US$) in Argentina and Value added (constant 2005 US$) in Brazil?
Your answer should be very brief. -4.11e+11. In the year 2007, what is the difference between the Value added (constant 2005 US$) in Argentina and Value added (constant 2005 US$) in Uganda?
Your answer should be very brief. 1.25e+11. In the year 2007, what is the difference between the Value added (constant 2005 US$) in Argentina and Value added (constant 2005 US$) in West Bank and Gaza?
Provide a succinct answer. 1.27e+11. In the year 2007, what is the difference between the Value added (constant 2005 US$) of Brazil and Value added (constant 2005 US$) of Uganda?
Your answer should be compact. 5.36e+11. In the year 2007, what is the difference between the Value added (constant 2005 US$) in Brazil and Value added (constant 2005 US$) in West Bank and Gaza?
Provide a succinct answer. 5.38e+11. In the year 2007, what is the difference between the Value added (constant 2005 US$) of Uganda and Value added (constant 2005 US$) of West Bank and Gaza?
Your response must be concise. 2.32e+09. In the year 2008, what is the difference between the Value added (constant 2005 US$) of Argentina and Value added (constant 2005 US$) of Brazil?
Make the answer very short. -4.26e+11. In the year 2008, what is the difference between the Value added (constant 2005 US$) in Argentina and Value added (constant 2005 US$) in Uganda?
Make the answer very short. 1.32e+11. In the year 2008, what is the difference between the Value added (constant 2005 US$) of Argentina and Value added (constant 2005 US$) of West Bank and Gaza?
Ensure brevity in your answer.  1.35e+11. In the year 2008, what is the difference between the Value added (constant 2005 US$) in Brazil and Value added (constant 2005 US$) in Uganda?
Your response must be concise. 5.58e+11. In the year 2008, what is the difference between the Value added (constant 2005 US$) of Brazil and Value added (constant 2005 US$) of West Bank and Gaza?
Provide a short and direct response. 5.61e+11. In the year 2008, what is the difference between the Value added (constant 2005 US$) of Uganda and Value added (constant 2005 US$) of West Bank and Gaza?
Offer a terse response. 3.15e+09. In the year 2009, what is the difference between the Value added (constant 2005 US$) of Argentina and Value added (constant 2005 US$) of Brazil?
Give a very brief answer. -4.30e+11. In the year 2009, what is the difference between the Value added (constant 2005 US$) in Argentina and Value added (constant 2005 US$) in Uganda?
Your answer should be compact. 1.34e+11. In the year 2009, what is the difference between the Value added (constant 2005 US$) in Argentina and Value added (constant 2005 US$) in West Bank and Gaza?
Your answer should be very brief. 1.36e+11. In the year 2009, what is the difference between the Value added (constant 2005 US$) of Brazil and Value added (constant 2005 US$) of Uganda?
Provide a succinct answer. 5.64e+11. In the year 2009, what is the difference between the Value added (constant 2005 US$) of Brazil and Value added (constant 2005 US$) of West Bank and Gaza?
Your answer should be very brief. 5.66e+11. In the year 2009, what is the difference between the Value added (constant 2005 US$) of Uganda and Value added (constant 2005 US$) of West Bank and Gaza?
Offer a very short reply. 2.31e+09. In the year 2010, what is the difference between the Value added (constant 2005 US$) in Argentina and Value added (constant 2005 US$) in Brazil?
Provide a short and direct response. -4.49e+11. In the year 2010, what is the difference between the Value added (constant 2005 US$) in Argentina and Value added (constant 2005 US$) in Uganda?
Make the answer very short. 1.46e+11. In the year 2010, what is the difference between the Value added (constant 2005 US$) in Argentina and Value added (constant 2005 US$) in West Bank and Gaza?
Your answer should be compact. 1.49e+11. In the year 2010, what is the difference between the Value added (constant 2005 US$) of Brazil and Value added (constant 2005 US$) of Uganda?
Give a very brief answer. 5.95e+11. In the year 2010, what is the difference between the Value added (constant 2005 US$) of Brazil and Value added (constant 2005 US$) of West Bank and Gaza?
Ensure brevity in your answer.  5.97e+11. In the year 2010, what is the difference between the Value added (constant 2005 US$) of Uganda and Value added (constant 2005 US$) of West Bank and Gaza?
Offer a terse response. 2.50e+09. In the year 2011, what is the difference between the Value added (constant 2005 US$) in Argentina and Value added (constant 2005 US$) in Brazil?
Give a very brief answer. -4.59e+11. In the year 2011, what is the difference between the Value added (constant 2005 US$) of Argentina and Value added (constant 2005 US$) of Uganda?
Provide a short and direct response. 1.59e+11. In the year 2011, what is the difference between the Value added (constant 2005 US$) of Argentina and Value added (constant 2005 US$) of West Bank and Gaza?
Make the answer very short. 1.62e+11. In the year 2011, what is the difference between the Value added (constant 2005 US$) in Brazil and Value added (constant 2005 US$) in Uganda?
Ensure brevity in your answer.  6.18e+11. In the year 2011, what is the difference between the Value added (constant 2005 US$) in Brazil and Value added (constant 2005 US$) in West Bank and Gaza?
Provide a succinct answer. 6.21e+11. In the year 2011, what is the difference between the Value added (constant 2005 US$) of Uganda and Value added (constant 2005 US$) of West Bank and Gaza?
Offer a terse response. 2.81e+09. In the year 2012, what is the difference between the Value added (constant 2005 US$) in Argentina and Value added (constant 2005 US$) in Brazil?
Keep it short and to the point. -4.65e+11. In the year 2012, what is the difference between the Value added (constant 2005 US$) in Argentina and Value added (constant 2005 US$) in Uganda?
Keep it short and to the point. 1.64e+11. In the year 2012, what is the difference between the Value added (constant 2005 US$) in Argentina and Value added (constant 2005 US$) in West Bank and Gaza?
Ensure brevity in your answer.  1.67e+11. In the year 2012, what is the difference between the Value added (constant 2005 US$) in Brazil and Value added (constant 2005 US$) in Uganda?
Your response must be concise. 6.30e+11. In the year 2012, what is the difference between the Value added (constant 2005 US$) in Brazil and Value added (constant 2005 US$) in West Bank and Gaza?
Give a very brief answer. 6.32e+11. In the year 2012, what is the difference between the Value added (constant 2005 US$) in Uganda and Value added (constant 2005 US$) in West Bank and Gaza?
Make the answer very short. 2.56e+09. What is the ratio of the Value added (constant 2005 US$) in Argentina in 2006 to that in 2007?
Offer a very short reply. 0.92. What is the ratio of the Value added (constant 2005 US$) of Uganda in 2006 to that in 2007?
Your answer should be very brief. 0.93. What is the ratio of the Value added (constant 2005 US$) in West Bank and Gaza in 2006 to that in 2007?
Make the answer very short. 1.06. What is the ratio of the Value added (constant 2005 US$) in Argentina in 2006 to that in 2008?
Offer a very short reply. 0.87. What is the ratio of the Value added (constant 2005 US$) in Brazil in 2006 to that in 2008?
Give a very brief answer. 0.91. What is the ratio of the Value added (constant 2005 US$) of Uganda in 2006 to that in 2008?
Give a very brief answer. 0.84. What is the ratio of the Value added (constant 2005 US$) in West Bank and Gaza in 2006 to that in 2008?
Offer a very short reply. 1.22. What is the ratio of the Value added (constant 2005 US$) in Argentina in 2006 to that in 2009?
Your answer should be compact. 0.86. What is the ratio of the Value added (constant 2005 US$) of Brazil in 2006 to that in 2009?
Keep it short and to the point. 0.91. What is the ratio of the Value added (constant 2005 US$) in Uganda in 2006 to that in 2009?
Make the answer very short. 0.92. What is the ratio of the Value added (constant 2005 US$) in West Bank and Gaza in 2006 to that in 2009?
Your answer should be compact. 1.03. What is the ratio of the Value added (constant 2005 US$) of Argentina in 2006 to that in 2010?
Ensure brevity in your answer.  0.79. What is the ratio of the Value added (constant 2005 US$) in Brazil in 2006 to that in 2010?
Provide a short and direct response. 0.86. What is the ratio of the Value added (constant 2005 US$) in Uganda in 2006 to that in 2010?
Provide a succinct answer. 0.86. What is the ratio of the Value added (constant 2005 US$) in West Bank and Gaza in 2006 to that in 2010?
Offer a terse response. 0.99. What is the ratio of the Value added (constant 2005 US$) in Argentina in 2006 to that in 2011?
Your answer should be compact. 0.72. What is the ratio of the Value added (constant 2005 US$) of Brazil in 2006 to that in 2011?
Offer a very short reply. 0.82. What is the ratio of the Value added (constant 2005 US$) of Uganda in 2006 to that in 2011?
Provide a succinct answer. 0.77. What is the ratio of the Value added (constant 2005 US$) in West Bank and Gaza in 2006 to that in 2011?
Offer a terse response. 0.88. What is the ratio of the Value added (constant 2005 US$) of Argentina in 2006 to that in 2012?
Offer a very short reply. 0.7. What is the ratio of the Value added (constant 2005 US$) in Brazil in 2006 to that in 2012?
Your answer should be compact. 0.81. What is the ratio of the Value added (constant 2005 US$) in Uganda in 2006 to that in 2012?
Ensure brevity in your answer.  0.73. What is the ratio of the Value added (constant 2005 US$) of West Bank and Gaza in 2006 to that in 2012?
Make the answer very short. 0.75. What is the ratio of the Value added (constant 2005 US$) of Argentina in 2007 to that in 2008?
Ensure brevity in your answer.  0.95. What is the ratio of the Value added (constant 2005 US$) of Brazil in 2007 to that in 2008?
Give a very brief answer. 0.96. What is the ratio of the Value added (constant 2005 US$) in Uganda in 2007 to that in 2008?
Provide a succinct answer. 0.91. What is the ratio of the Value added (constant 2005 US$) of West Bank and Gaza in 2007 to that in 2008?
Offer a very short reply. 1.16. What is the ratio of the Value added (constant 2005 US$) of Argentina in 2007 to that in 2009?
Ensure brevity in your answer.  0.94. What is the ratio of the Value added (constant 2005 US$) in Brazil in 2007 to that in 2009?
Offer a very short reply. 0.95. What is the ratio of the Value added (constant 2005 US$) in West Bank and Gaza in 2007 to that in 2009?
Keep it short and to the point. 0.98. What is the ratio of the Value added (constant 2005 US$) in Argentina in 2007 to that in 2010?
Provide a succinct answer. 0.86. What is the ratio of the Value added (constant 2005 US$) in Brazil in 2007 to that in 2010?
Ensure brevity in your answer.  0.9. What is the ratio of the Value added (constant 2005 US$) in Uganda in 2007 to that in 2010?
Your answer should be very brief. 0.93. What is the ratio of the Value added (constant 2005 US$) in West Bank and Gaza in 2007 to that in 2010?
Your response must be concise. 0.94. What is the ratio of the Value added (constant 2005 US$) in Argentina in 2007 to that in 2011?
Make the answer very short. 0.79. What is the ratio of the Value added (constant 2005 US$) in Brazil in 2007 to that in 2011?
Give a very brief answer. 0.87. What is the ratio of the Value added (constant 2005 US$) of Uganda in 2007 to that in 2011?
Provide a short and direct response. 0.83. What is the ratio of the Value added (constant 2005 US$) of West Bank and Gaza in 2007 to that in 2011?
Give a very brief answer. 0.84. What is the ratio of the Value added (constant 2005 US$) in Argentina in 2007 to that in 2012?
Your answer should be compact. 0.76. What is the ratio of the Value added (constant 2005 US$) in Brazil in 2007 to that in 2012?
Make the answer very short. 0.85. What is the ratio of the Value added (constant 2005 US$) in Uganda in 2007 to that in 2012?
Offer a very short reply. 0.79. What is the ratio of the Value added (constant 2005 US$) of West Bank and Gaza in 2007 to that in 2012?
Provide a short and direct response. 0.71. What is the ratio of the Value added (constant 2005 US$) of Argentina in 2008 to that in 2009?
Your response must be concise. 0.99. What is the ratio of the Value added (constant 2005 US$) in Brazil in 2008 to that in 2009?
Your answer should be very brief. 0.99. What is the ratio of the Value added (constant 2005 US$) of Uganda in 2008 to that in 2009?
Give a very brief answer. 1.09. What is the ratio of the Value added (constant 2005 US$) of West Bank and Gaza in 2008 to that in 2009?
Provide a short and direct response. 0.85. What is the ratio of the Value added (constant 2005 US$) in Argentina in 2008 to that in 2010?
Offer a terse response. 0.91. What is the ratio of the Value added (constant 2005 US$) of Brazil in 2008 to that in 2010?
Provide a succinct answer. 0.94. What is the ratio of the Value added (constant 2005 US$) of Uganda in 2008 to that in 2010?
Your answer should be very brief. 1.02. What is the ratio of the Value added (constant 2005 US$) of West Bank and Gaza in 2008 to that in 2010?
Ensure brevity in your answer.  0.81. What is the ratio of the Value added (constant 2005 US$) in Argentina in 2008 to that in 2011?
Provide a succinct answer. 0.83. What is the ratio of the Value added (constant 2005 US$) in Brazil in 2008 to that in 2011?
Offer a very short reply. 0.9. What is the ratio of the Value added (constant 2005 US$) of Uganda in 2008 to that in 2011?
Give a very brief answer. 0.91. What is the ratio of the Value added (constant 2005 US$) of West Bank and Gaza in 2008 to that in 2011?
Your answer should be very brief. 0.72. What is the ratio of the Value added (constant 2005 US$) in Argentina in 2008 to that in 2012?
Your answer should be compact. 0.81. What is the ratio of the Value added (constant 2005 US$) of Brazil in 2008 to that in 2012?
Ensure brevity in your answer.  0.89. What is the ratio of the Value added (constant 2005 US$) of Uganda in 2008 to that in 2012?
Your answer should be compact. 0.87. What is the ratio of the Value added (constant 2005 US$) of West Bank and Gaza in 2008 to that in 2012?
Keep it short and to the point. 0.62. What is the ratio of the Value added (constant 2005 US$) of Argentina in 2009 to that in 2010?
Your response must be concise. 0.92. What is the ratio of the Value added (constant 2005 US$) in Brazil in 2009 to that in 2010?
Your answer should be very brief. 0.95. What is the ratio of the Value added (constant 2005 US$) of Uganda in 2009 to that in 2010?
Make the answer very short. 0.94. What is the ratio of the Value added (constant 2005 US$) in West Bank and Gaza in 2009 to that in 2010?
Offer a terse response. 0.96. What is the ratio of the Value added (constant 2005 US$) in Argentina in 2009 to that in 2011?
Your answer should be compact. 0.84. What is the ratio of the Value added (constant 2005 US$) of Brazil in 2009 to that in 2011?
Offer a terse response. 0.91. What is the ratio of the Value added (constant 2005 US$) in Uganda in 2009 to that in 2011?
Your answer should be very brief. 0.84. What is the ratio of the Value added (constant 2005 US$) in West Bank and Gaza in 2009 to that in 2011?
Your response must be concise. 0.85. What is the ratio of the Value added (constant 2005 US$) of Argentina in 2009 to that in 2012?
Offer a terse response. 0.81. What is the ratio of the Value added (constant 2005 US$) in Brazil in 2009 to that in 2012?
Provide a short and direct response. 0.89. What is the ratio of the Value added (constant 2005 US$) in Uganda in 2009 to that in 2012?
Provide a succinct answer. 0.8. What is the ratio of the Value added (constant 2005 US$) of West Bank and Gaza in 2009 to that in 2012?
Ensure brevity in your answer.  0.73. What is the ratio of the Value added (constant 2005 US$) of Argentina in 2010 to that in 2011?
Provide a short and direct response. 0.92. What is the ratio of the Value added (constant 2005 US$) of Brazil in 2010 to that in 2011?
Your response must be concise. 0.96. What is the ratio of the Value added (constant 2005 US$) in Uganda in 2010 to that in 2011?
Your answer should be very brief. 0.89. What is the ratio of the Value added (constant 2005 US$) of West Bank and Gaza in 2010 to that in 2011?
Offer a very short reply. 0.89. What is the ratio of the Value added (constant 2005 US$) in Argentina in 2010 to that in 2012?
Your answer should be compact. 0.89. What is the ratio of the Value added (constant 2005 US$) of Brazil in 2010 to that in 2012?
Make the answer very short. 0.94. What is the ratio of the Value added (constant 2005 US$) in Uganda in 2010 to that in 2012?
Provide a short and direct response. 0.85. What is the ratio of the Value added (constant 2005 US$) in West Bank and Gaza in 2010 to that in 2012?
Your answer should be compact. 0.76. What is the ratio of the Value added (constant 2005 US$) of Argentina in 2011 to that in 2012?
Your answer should be very brief. 0.97. What is the ratio of the Value added (constant 2005 US$) in Brazil in 2011 to that in 2012?
Your response must be concise. 0.98. What is the ratio of the Value added (constant 2005 US$) of Uganda in 2011 to that in 2012?
Keep it short and to the point. 0.95. What is the ratio of the Value added (constant 2005 US$) in West Bank and Gaza in 2011 to that in 2012?
Your answer should be very brief. 0.85. What is the difference between the highest and the second highest Value added (constant 2005 US$) of Argentina?
Provide a short and direct response. 5.24e+09. What is the difference between the highest and the second highest Value added (constant 2005 US$) of Brazil?
Your answer should be very brief. 1.14e+1. What is the difference between the highest and the second highest Value added (constant 2005 US$) in Uganda?
Offer a terse response. 2.94e+08. What is the difference between the highest and the second highest Value added (constant 2005 US$) in West Bank and Gaza?
Give a very brief answer. 5.42e+08. What is the difference between the highest and the lowest Value added (constant 2005 US$) of Argentina?
Make the answer very short. 5.11e+1. What is the difference between the highest and the lowest Value added (constant 2005 US$) in Brazil?
Your answer should be compact. 1.21e+11. What is the difference between the highest and the lowest Value added (constant 2005 US$) of Uganda?
Provide a succinct answer. 1.67e+09. What is the difference between the highest and the lowest Value added (constant 2005 US$) in West Bank and Gaza?
Provide a short and direct response. 1.41e+09. 